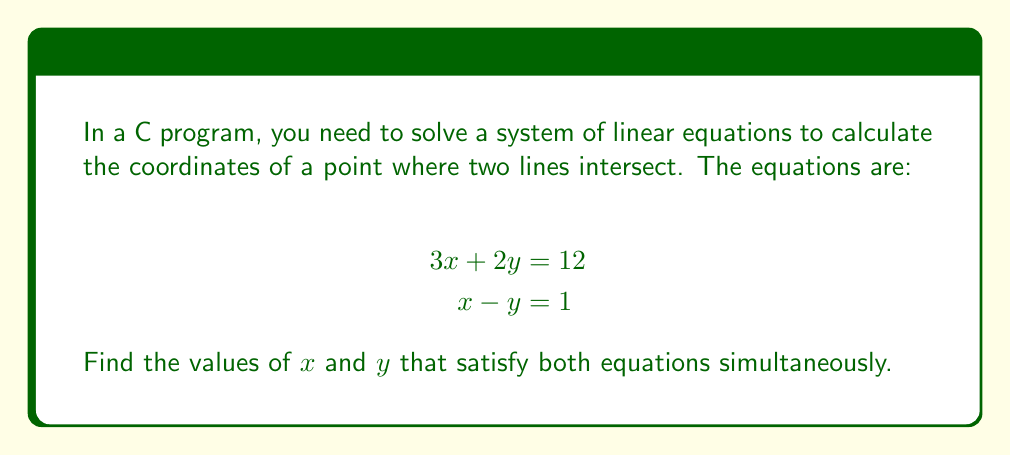Give your solution to this math problem. Let's solve this system of equations using the substitution method:

1) From the second equation, we can express $x$ in terms of $y$:
   $$x - y = 1$$
   $$x = y + 1$$

2) Substitute this expression for $x$ into the first equation:
   $$3(y + 1) + 2y = 12$$

3) Simplify:
   $$3y + 3 + 2y = 12$$
   $$5y + 3 = 12$$

4) Subtract 3 from both sides:
   $$5y = 9$$

5) Divide both sides by 5:
   $$y = \frac{9}{5} = 1.8$$

6) Now that we know $y$, we can find $x$ using the equation from step 1:
   $$x = y + 1 = 1.8 + 1 = 2.8$$

Therefore, the solution is $x = 2.8$ and $y = 1.8$.

In C programming, you would typically store these values as floating-point numbers (float or double).
Answer: $x = 2.8$, $y = 1.8$ 